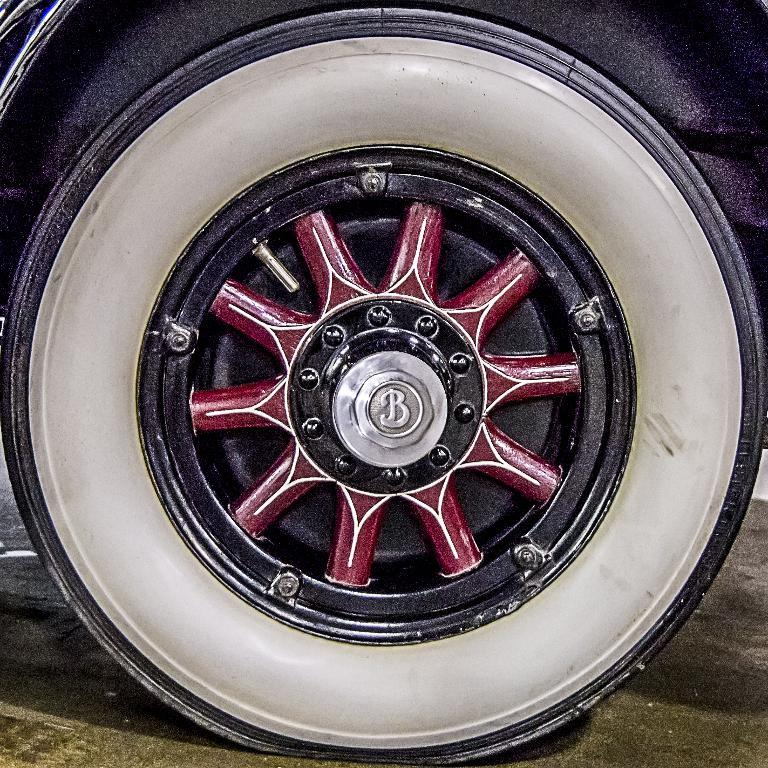What is the main subject of the image? The main subject of the image is a wheel of a vehicle. Where is the wheel located in the image? The wheel is on the ground. What type of teeth can be seen on the ghost in the image? There is no ghost or teeth present in the image; it features a wheel of a vehicle on the ground. 